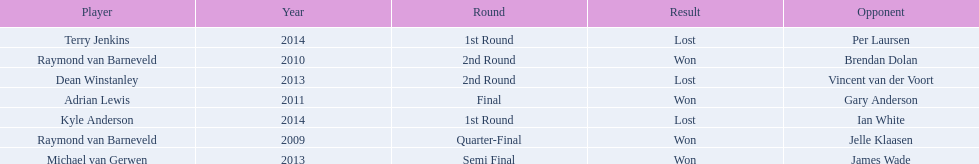Did terry jenkins win in 2014? Terry Jenkins, Lost. If terry jenkins lost who won? Per Laursen. 